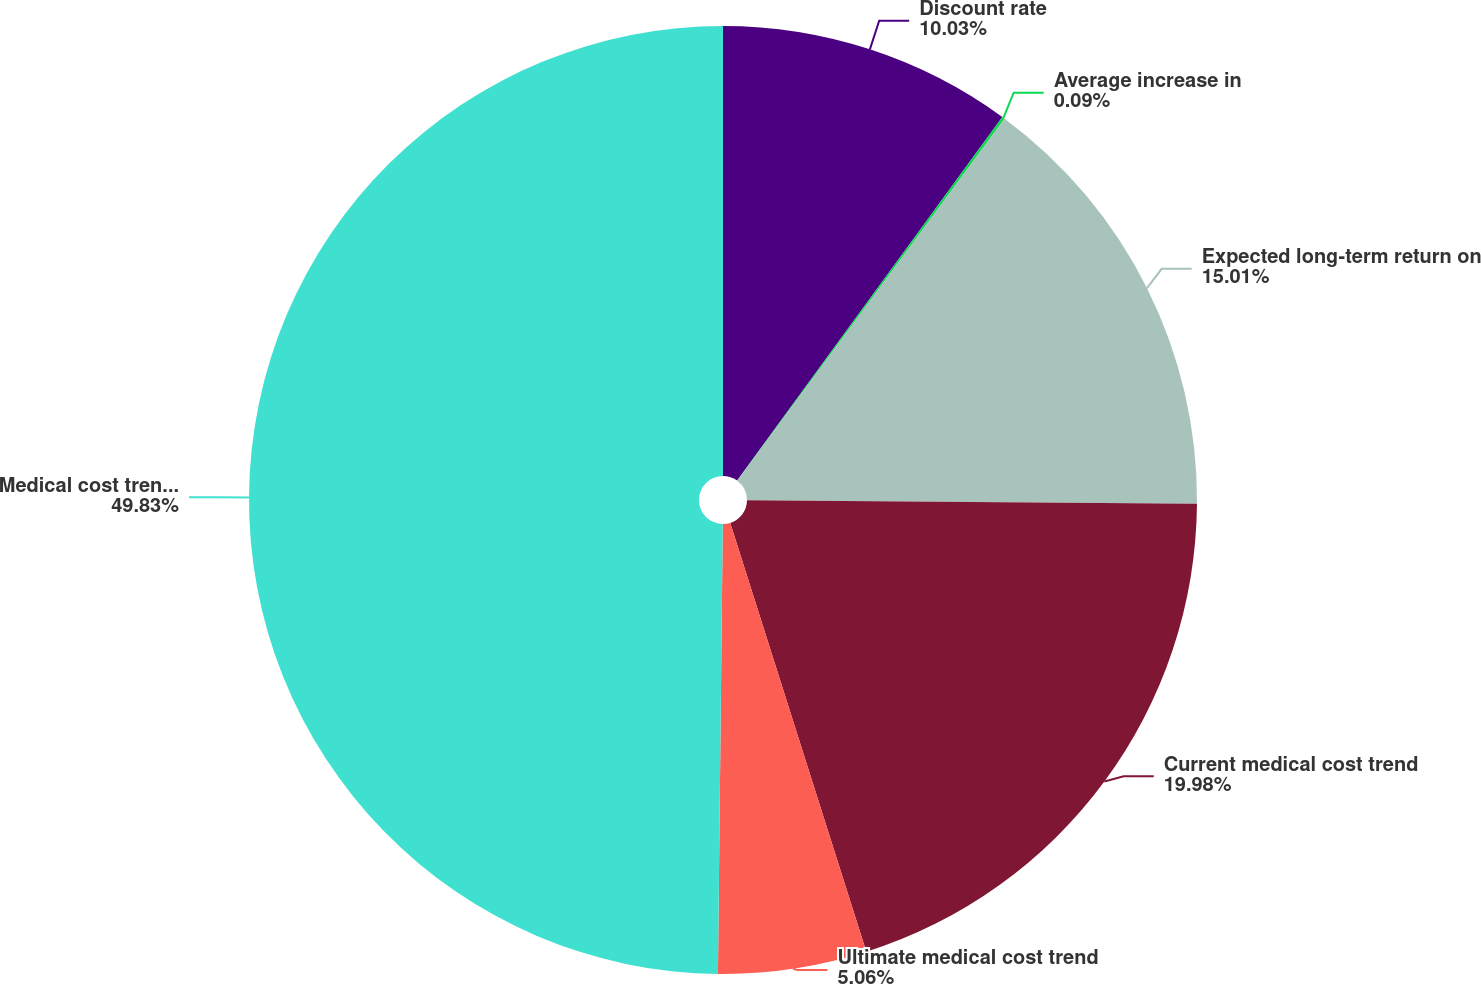Convert chart to OTSL. <chart><loc_0><loc_0><loc_500><loc_500><pie_chart><fcel>Discount rate<fcel>Average increase in<fcel>Expected long-term return on<fcel>Current medical cost trend<fcel>Ultimate medical cost trend<fcel>Medical cost trend rate<nl><fcel>10.03%<fcel>0.09%<fcel>15.01%<fcel>19.98%<fcel>5.06%<fcel>49.83%<nl></chart> 